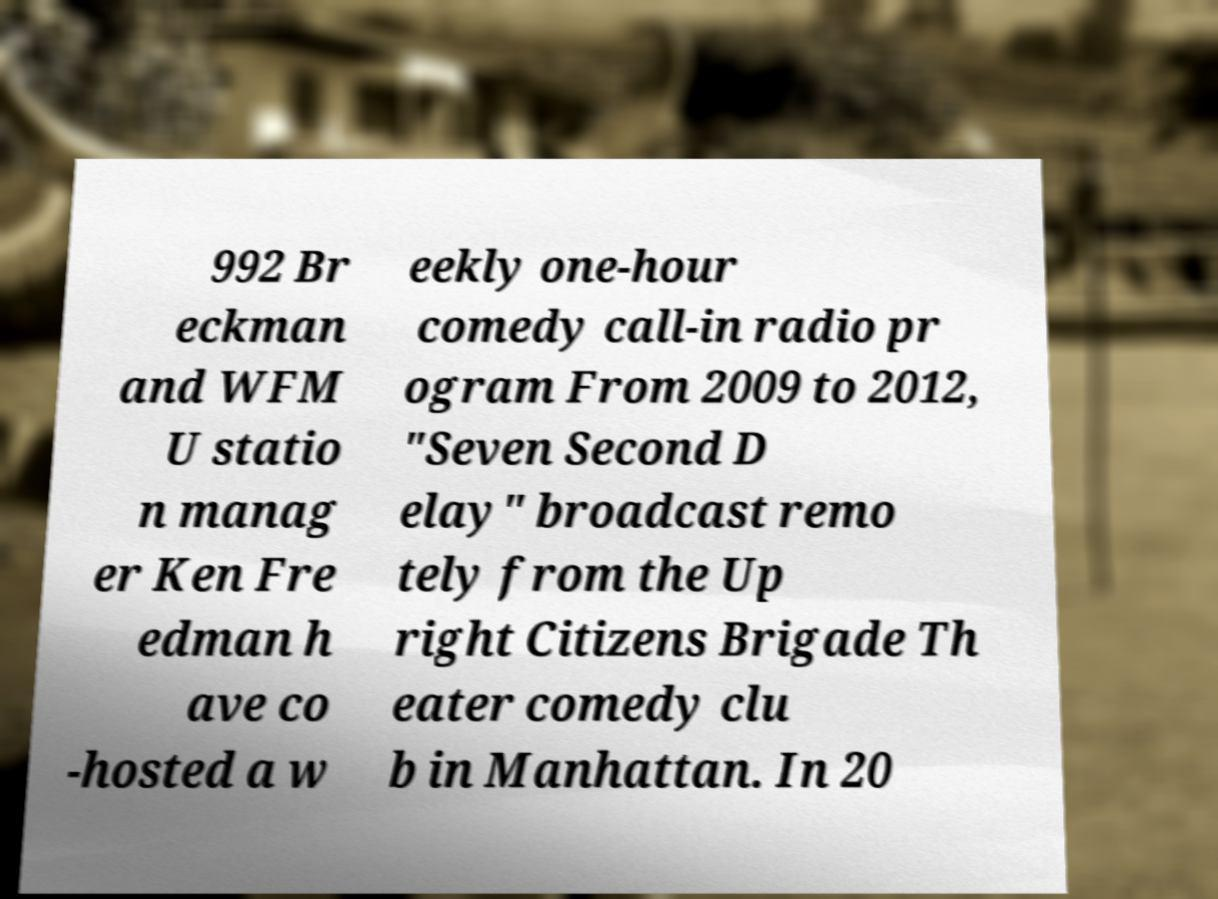Please read and relay the text visible in this image. What does it say? 992 Br eckman and WFM U statio n manag er Ken Fre edman h ave co -hosted a w eekly one-hour comedy call-in radio pr ogram From 2009 to 2012, "Seven Second D elay" broadcast remo tely from the Up right Citizens Brigade Th eater comedy clu b in Manhattan. In 20 